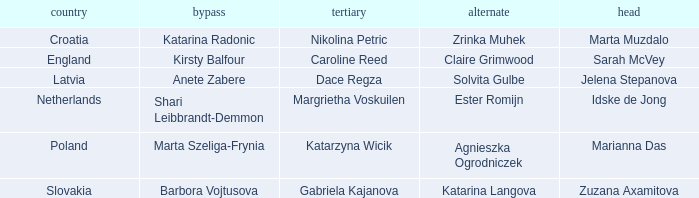Which lead has Kirsty Balfour as second? Sarah McVey. 